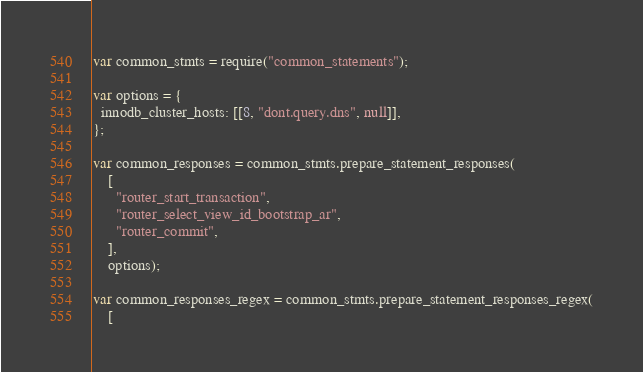<code> <loc_0><loc_0><loc_500><loc_500><_JavaScript_>var common_stmts = require("common_statements");

var options = {
  innodb_cluster_hosts: [[8, "dont.query.dns", null]],
};

var common_responses = common_stmts.prepare_statement_responses(
    [
      "router_start_transaction",
      "router_select_view_id_bootstrap_ar",
      "router_commit",
    ],
    options);

var common_responses_regex = common_stmts.prepare_statement_responses_regex(
    [</code> 